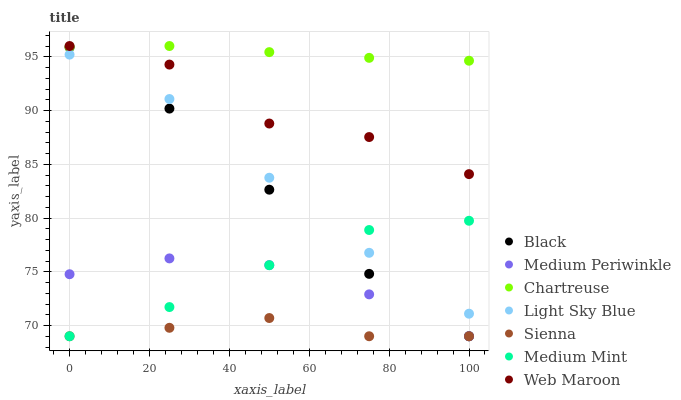Does Sienna have the minimum area under the curve?
Answer yes or no. Yes. Does Chartreuse have the maximum area under the curve?
Answer yes or no. Yes. Does Web Maroon have the minimum area under the curve?
Answer yes or no. No. Does Web Maroon have the maximum area under the curve?
Answer yes or no. No. Is Chartreuse the smoothest?
Answer yes or no. Yes. Is Web Maroon the roughest?
Answer yes or no. Yes. Is Medium Periwinkle the smoothest?
Answer yes or no. No. Is Medium Periwinkle the roughest?
Answer yes or no. No. Does Medium Mint have the lowest value?
Answer yes or no. Yes. Does Web Maroon have the lowest value?
Answer yes or no. No. Does Chartreuse have the highest value?
Answer yes or no. Yes. Does Medium Periwinkle have the highest value?
Answer yes or no. No. Is Medium Periwinkle less than Chartreuse?
Answer yes or no. Yes. Is Web Maroon greater than Medium Periwinkle?
Answer yes or no. Yes. Does Chartreuse intersect Web Maroon?
Answer yes or no. Yes. Is Chartreuse less than Web Maroon?
Answer yes or no. No. Is Chartreuse greater than Web Maroon?
Answer yes or no. No. Does Medium Periwinkle intersect Chartreuse?
Answer yes or no. No. 